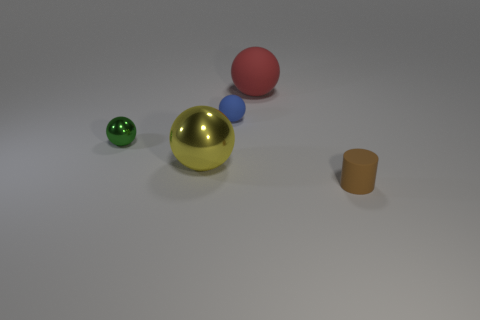Subtract all blue spheres. Subtract all red cylinders. How many spheres are left? 3 Add 3 small green metallic objects. How many objects exist? 8 Subtract all balls. How many objects are left? 1 Subtract 0 green blocks. How many objects are left? 5 Subtract all large metallic objects. Subtract all green shiny things. How many objects are left? 3 Add 4 brown rubber objects. How many brown rubber objects are left? 5 Add 5 rubber balls. How many rubber balls exist? 7 